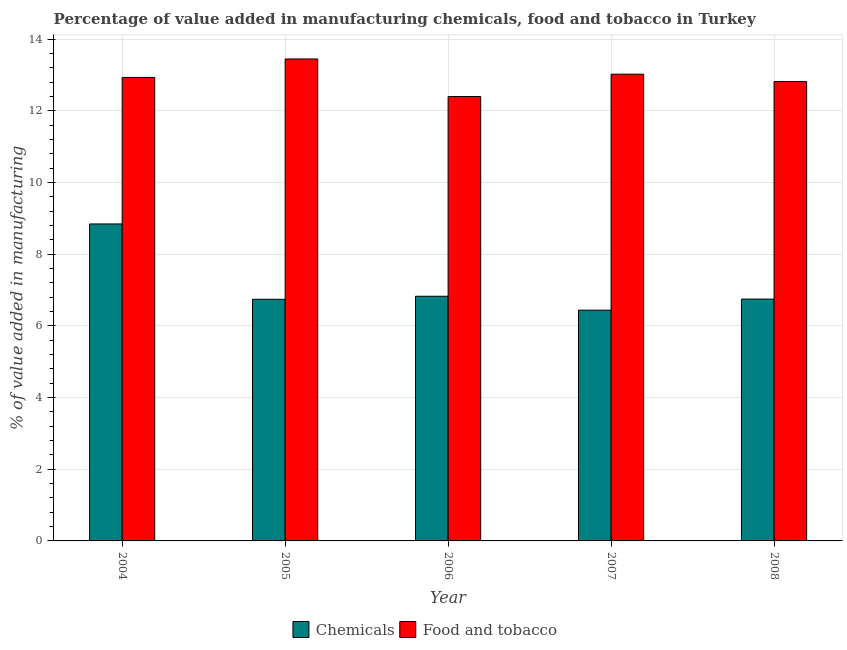How many different coloured bars are there?
Offer a terse response. 2. How many groups of bars are there?
Make the answer very short. 5. Are the number of bars on each tick of the X-axis equal?
Provide a short and direct response. Yes. How many bars are there on the 3rd tick from the left?
Provide a short and direct response. 2. What is the value added by manufacturing food and tobacco in 2004?
Keep it short and to the point. 12.93. Across all years, what is the maximum value added by manufacturing food and tobacco?
Keep it short and to the point. 13.45. Across all years, what is the minimum value added by manufacturing food and tobacco?
Keep it short and to the point. 12.4. In which year was the value added by  manufacturing chemicals maximum?
Provide a short and direct response. 2004. What is the total value added by  manufacturing chemicals in the graph?
Keep it short and to the point. 35.59. What is the difference between the value added by manufacturing food and tobacco in 2006 and that in 2007?
Provide a short and direct response. -0.62. What is the difference between the value added by manufacturing food and tobacco in 2004 and the value added by  manufacturing chemicals in 2007?
Your response must be concise. -0.09. What is the average value added by manufacturing food and tobacco per year?
Offer a very short reply. 12.92. What is the ratio of the value added by  manufacturing chemicals in 2004 to that in 2005?
Provide a succinct answer. 1.31. Is the value added by  manufacturing chemicals in 2005 less than that in 2007?
Ensure brevity in your answer.  No. What is the difference between the highest and the second highest value added by  manufacturing chemicals?
Your answer should be very brief. 2.02. What is the difference between the highest and the lowest value added by  manufacturing chemicals?
Keep it short and to the point. 2.41. In how many years, is the value added by manufacturing food and tobacco greater than the average value added by manufacturing food and tobacco taken over all years?
Provide a short and direct response. 3. Is the sum of the value added by manufacturing food and tobacco in 2005 and 2006 greater than the maximum value added by  manufacturing chemicals across all years?
Make the answer very short. Yes. What does the 2nd bar from the left in 2007 represents?
Provide a short and direct response. Food and tobacco. What does the 2nd bar from the right in 2007 represents?
Offer a very short reply. Chemicals. How many years are there in the graph?
Offer a very short reply. 5. What is the difference between two consecutive major ticks on the Y-axis?
Ensure brevity in your answer.  2. Are the values on the major ticks of Y-axis written in scientific E-notation?
Give a very brief answer. No. Where does the legend appear in the graph?
Ensure brevity in your answer.  Bottom center. How many legend labels are there?
Your answer should be very brief. 2. How are the legend labels stacked?
Your answer should be compact. Horizontal. What is the title of the graph?
Make the answer very short. Percentage of value added in manufacturing chemicals, food and tobacco in Turkey. Does "Researchers" appear as one of the legend labels in the graph?
Your answer should be compact. No. What is the label or title of the Y-axis?
Offer a terse response. % of value added in manufacturing. What is the % of value added in manufacturing in Chemicals in 2004?
Make the answer very short. 8.84. What is the % of value added in manufacturing of Food and tobacco in 2004?
Offer a terse response. 12.93. What is the % of value added in manufacturing in Chemicals in 2005?
Your answer should be compact. 6.74. What is the % of value added in manufacturing of Food and tobacco in 2005?
Keep it short and to the point. 13.45. What is the % of value added in manufacturing of Chemicals in 2006?
Your response must be concise. 6.83. What is the % of value added in manufacturing of Food and tobacco in 2006?
Ensure brevity in your answer.  12.4. What is the % of value added in manufacturing of Chemicals in 2007?
Provide a short and direct response. 6.44. What is the % of value added in manufacturing of Food and tobacco in 2007?
Keep it short and to the point. 13.02. What is the % of value added in manufacturing of Chemicals in 2008?
Your answer should be compact. 6.75. What is the % of value added in manufacturing in Food and tobacco in 2008?
Your response must be concise. 12.82. Across all years, what is the maximum % of value added in manufacturing in Chemicals?
Your response must be concise. 8.84. Across all years, what is the maximum % of value added in manufacturing of Food and tobacco?
Keep it short and to the point. 13.45. Across all years, what is the minimum % of value added in manufacturing in Chemicals?
Keep it short and to the point. 6.44. Across all years, what is the minimum % of value added in manufacturing in Food and tobacco?
Give a very brief answer. 12.4. What is the total % of value added in manufacturing in Chemicals in the graph?
Offer a terse response. 35.59. What is the total % of value added in manufacturing in Food and tobacco in the graph?
Provide a short and direct response. 64.61. What is the difference between the % of value added in manufacturing of Chemicals in 2004 and that in 2005?
Make the answer very short. 2.1. What is the difference between the % of value added in manufacturing of Food and tobacco in 2004 and that in 2005?
Provide a succinct answer. -0.51. What is the difference between the % of value added in manufacturing in Chemicals in 2004 and that in 2006?
Provide a succinct answer. 2.02. What is the difference between the % of value added in manufacturing of Food and tobacco in 2004 and that in 2006?
Make the answer very short. 0.53. What is the difference between the % of value added in manufacturing in Chemicals in 2004 and that in 2007?
Make the answer very short. 2.41. What is the difference between the % of value added in manufacturing in Food and tobacco in 2004 and that in 2007?
Your response must be concise. -0.09. What is the difference between the % of value added in manufacturing of Chemicals in 2004 and that in 2008?
Give a very brief answer. 2.1. What is the difference between the % of value added in manufacturing of Food and tobacco in 2004 and that in 2008?
Your answer should be compact. 0.12. What is the difference between the % of value added in manufacturing of Chemicals in 2005 and that in 2006?
Your response must be concise. -0.08. What is the difference between the % of value added in manufacturing of Food and tobacco in 2005 and that in 2006?
Make the answer very short. 1.05. What is the difference between the % of value added in manufacturing of Chemicals in 2005 and that in 2007?
Offer a terse response. 0.3. What is the difference between the % of value added in manufacturing of Food and tobacco in 2005 and that in 2007?
Make the answer very short. 0.42. What is the difference between the % of value added in manufacturing of Chemicals in 2005 and that in 2008?
Your response must be concise. -0.01. What is the difference between the % of value added in manufacturing in Food and tobacco in 2005 and that in 2008?
Ensure brevity in your answer.  0.63. What is the difference between the % of value added in manufacturing of Chemicals in 2006 and that in 2007?
Ensure brevity in your answer.  0.39. What is the difference between the % of value added in manufacturing of Food and tobacco in 2006 and that in 2007?
Offer a very short reply. -0.62. What is the difference between the % of value added in manufacturing in Chemicals in 2006 and that in 2008?
Offer a terse response. 0.08. What is the difference between the % of value added in manufacturing of Food and tobacco in 2006 and that in 2008?
Give a very brief answer. -0.42. What is the difference between the % of value added in manufacturing in Chemicals in 2007 and that in 2008?
Make the answer very short. -0.31. What is the difference between the % of value added in manufacturing of Food and tobacco in 2007 and that in 2008?
Ensure brevity in your answer.  0.21. What is the difference between the % of value added in manufacturing of Chemicals in 2004 and the % of value added in manufacturing of Food and tobacco in 2005?
Make the answer very short. -4.6. What is the difference between the % of value added in manufacturing in Chemicals in 2004 and the % of value added in manufacturing in Food and tobacco in 2006?
Your answer should be compact. -3.56. What is the difference between the % of value added in manufacturing of Chemicals in 2004 and the % of value added in manufacturing of Food and tobacco in 2007?
Your response must be concise. -4.18. What is the difference between the % of value added in manufacturing in Chemicals in 2004 and the % of value added in manufacturing in Food and tobacco in 2008?
Your response must be concise. -3.97. What is the difference between the % of value added in manufacturing of Chemicals in 2005 and the % of value added in manufacturing of Food and tobacco in 2006?
Your answer should be compact. -5.66. What is the difference between the % of value added in manufacturing of Chemicals in 2005 and the % of value added in manufacturing of Food and tobacco in 2007?
Your response must be concise. -6.28. What is the difference between the % of value added in manufacturing of Chemicals in 2005 and the % of value added in manufacturing of Food and tobacco in 2008?
Your answer should be very brief. -6.08. What is the difference between the % of value added in manufacturing of Chemicals in 2006 and the % of value added in manufacturing of Food and tobacco in 2007?
Offer a terse response. -6.2. What is the difference between the % of value added in manufacturing of Chemicals in 2006 and the % of value added in manufacturing of Food and tobacco in 2008?
Make the answer very short. -5.99. What is the difference between the % of value added in manufacturing in Chemicals in 2007 and the % of value added in manufacturing in Food and tobacco in 2008?
Make the answer very short. -6.38. What is the average % of value added in manufacturing of Chemicals per year?
Offer a terse response. 7.12. What is the average % of value added in manufacturing in Food and tobacco per year?
Your response must be concise. 12.92. In the year 2004, what is the difference between the % of value added in manufacturing of Chemicals and % of value added in manufacturing of Food and tobacco?
Offer a terse response. -4.09. In the year 2005, what is the difference between the % of value added in manufacturing of Chemicals and % of value added in manufacturing of Food and tobacco?
Offer a very short reply. -6.7. In the year 2006, what is the difference between the % of value added in manufacturing in Chemicals and % of value added in manufacturing in Food and tobacco?
Provide a short and direct response. -5.57. In the year 2007, what is the difference between the % of value added in manufacturing of Chemicals and % of value added in manufacturing of Food and tobacco?
Your answer should be compact. -6.58. In the year 2008, what is the difference between the % of value added in manufacturing in Chemicals and % of value added in manufacturing in Food and tobacco?
Provide a succinct answer. -6.07. What is the ratio of the % of value added in manufacturing of Chemicals in 2004 to that in 2005?
Offer a terse response. 1.31. What is the ratio of the % of value added in manufacturing of Food and tobacco in 2004 to that in 2005?
Offer a terse response. 0.96. What is the ratio of the % of value added in manufacturing of Chemicals in 2004 to that in 2006?
Make the answer very short. 1.3. What is the ratio of the % of value added in manufacturing of Food and tobacco in 2004 to that in 2006?
Give a very brief answer. 1.04. What is the ratio of the % of value added in manufacturing in Chemicals in 2004 to that in 2007?
Your response must be concise. 1.37. What is the ratio of the % of value added in manufacturing of Chemicals in 2004 to that in 2008?
Your answer should be very brief. 1.31. What is the ratio of the % of value added in manufacturing of Chemicals in 2005 to that in 2006?
Offer a very short reply. 0.99. What is the ratio of the % of value added in manufacturing of Food and tobacco in 2005 to that in 2006?
Your answer should be compact. 1.08. What is the ratio of the % of value added in manufacturing in Chemicals in 2005 to that in 2007?
Offer a very short reply. 1.05. What is the ratio of the % of value added in manufacturing of Food and tobacco in 2005 to that in 2007?
Provide a short and direct response. 1.03. What is the ratio of the % of value added in manufacturing of Chemicals in 2005 to that in 2008?
Ensure brevity in your answer.  1. What is the ratio of the % of value added in manufacturing of Food and tobacco in 2005 to that in 2008?
Your response must be concise. 1.05. What is the ratio of the % of value added in manufacturing of Chemicals in 2006 to that in 2007?
Provide a succinct answer. 1.06. What is the ratio of the % of value added in manufacturing of Food and tobacco in 2006 to that in 2007?
Offer a very short reply. 0.95. What is the ratio of the % of value added in manufacturing in Chemicals in 2006 to that in 2008?
Give a very brief answer. 1.01. What is the ratio of the % of value added in manufacturing of Food and tobacco in 2006 to that in 2008?
Your answer should be compact. 0.97. What is the ratio of the % of value added in manufacturing in Chemicals in 2007 to that in 2008?
Provide a short and direct response. 0.95. What is the ratio of the % of value added in manufacturing in Food and tobacco in 2007 to that in 2008?
Make the answer very short. 1.02. What is the difference between the highest and the second highest % of value added in manufacturing in Chemicals?
Provide a succinct answer. 2.02. What is the difference between the highest and the second highest % of value added in manufacturing of Food and tobacco?
Offer a very short reply. 0.42. What is the difference between the highest and the lowest % of value added in manufacturing in Chemicals?
Your answer should be compact. 2.41. What is the difference between the highest and the lowest % of value added in manufacturing in Food and tobacco?
Provide a short and direct response. 1.05. 